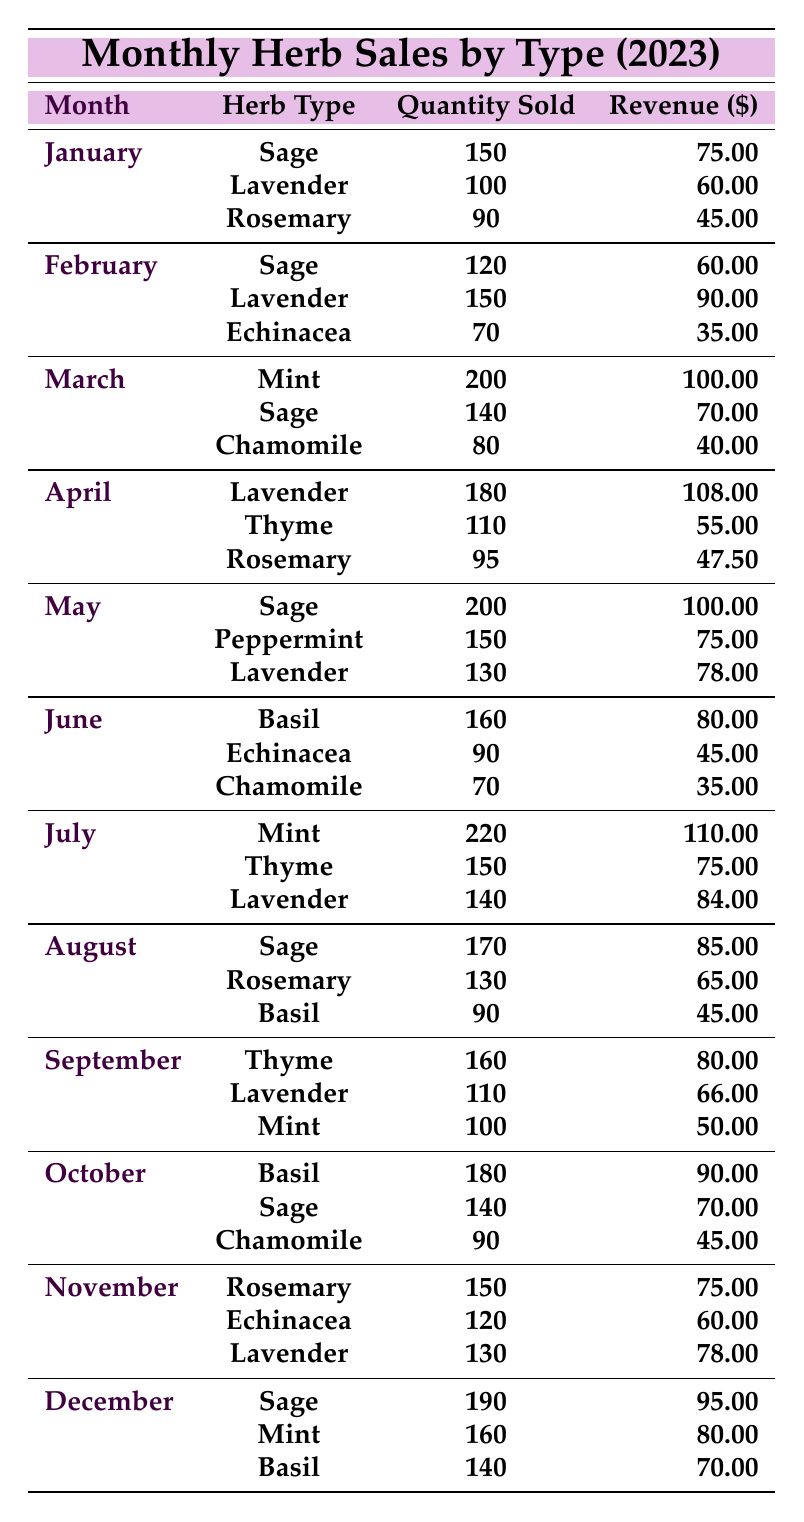What was the total revenue from Lavender in February? In February, Lavender sold 150 units for a revenue of $90. Therefore, the total revenue for Lavender in February is $90.
Answer: $90 How many units of Sage were sold in March? In March, Sage sold 140 units. The table directly provides this information.
Answer: 140 What is the total quantity of Basil sold from June to October? The units of Basil sold in June are 160, in August are 90, and in October are 180. Adding these amounts gives 160 + 90 + 180 = 430.
Answer: 430 Was Rosemary sold in all months from January to December? Looking at the table, Rosemary was not sold in April, May, June, July, August, September, or December, meaning it was sold in some but not all months.
Answer: No In which month did Sage generate the highest revenue? Reviewing the table, the highest revenue for Sage occurred in May, with $100 earned from selling 200 units.
Answer: May What is the average quantity of Echinacea sold per month? Echinacea was sold in February (70 units), June (90 units), and November (120 units), totaling 70 + 90 + 120 = 280 units. The average is 280 / 3 = 93.33.
Answer: 93.33 Which herb generated the most revenue in July? In July, Mint generated $110, which is higher than Lavender's $84 and Thyme's $75. Thus, Mint generated the most revenue in July.
Answer: Mint How much more revenue was generated from Thyme in September compared to April? Thyme generated $80 in September and $55 in April. The difference is $80 - $55 = $25.
Answer: $25 What was the total quantity of Lavender sold in the second quarter (April, May, June)? In April, 180 units of Lavender were sold, 130 in May, and none in June. Therefore, the total is 180 + 130 + 0 = 310 units.
Answer: 310 Was the total revenue from Mint in December more than from Sage in November? Mint generated $80 in December and Sage generated $75 in November, making Mint's revenue higher.
Answer: Yes 